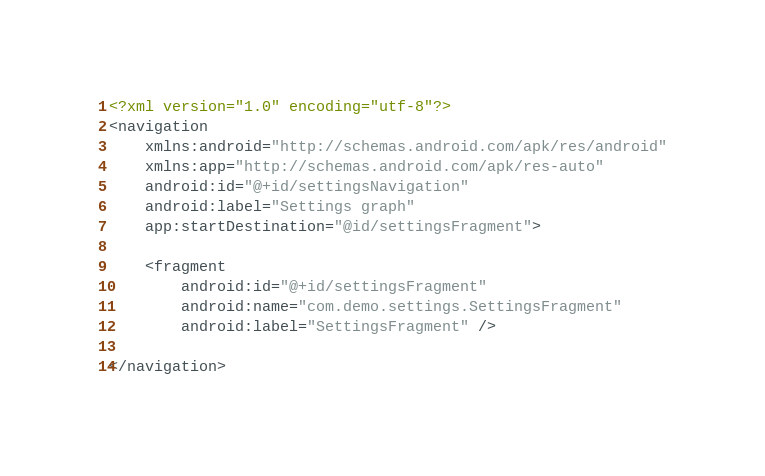Convert code to text. <code><loc_0><loc_0><loc_500><loc_500><_XML_><?xml version="1.0" encoding="utf-8"?>
<navigation
    xmlns:android="http://schemas.android.com/apk/res/android"
    xmlns:app="http://schemas.android.com/apk/res-auto"
    android:id="@+id/settingsNavigation"
    android:label="Settings graph"
    app:startDestination="@id/settingsFragment">

    <fragment
        android:id="@+id/settingsFragment"
        android:name="com.demo.settings.SettingsFragment"
        android:label="SettingsFragment" />

</navigation></code> 